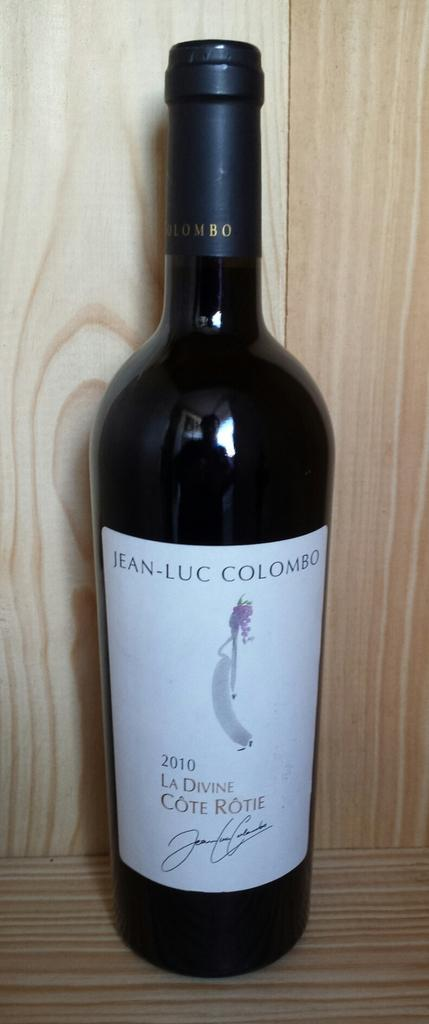What is the main subject of the image? The main subject of the image is a liquor bottle. Can you describe the liquor bottle in more detail? The liquor bottle has a white sticker on it. Where is the liquor bottle located in the image? The liquor bottle is placed in a wooden object. What type of hearing aid can be seen on the liquor bottle in the image? There is no hearing aid present on the liquor bottle in the image. How many ducks are swimming in the wooden object with the liquor bottle? There are no ducks present in the image. 